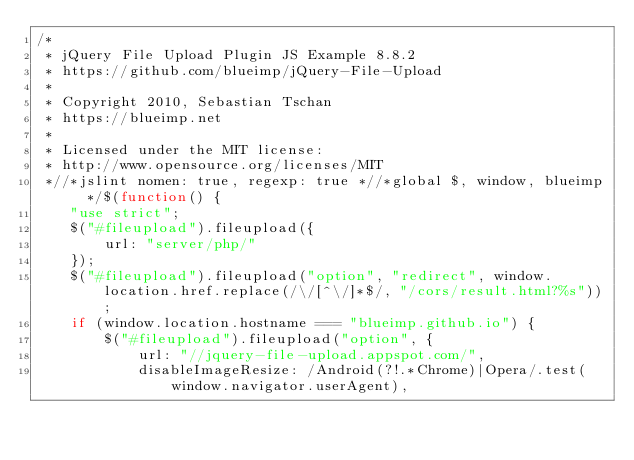Convert code to text. <code><loc_0><loc_0><loc_500><loc_500><_JavaScript_>/*
 * jQuery File Upload Plugin JS Example 8.8.2
 * https://github.com/blueimp/jQuery-File-Upload
 *
 * Copyright 2010, Sebastian Tschan
 * https://blueimp.net
 *
 * Licensed under the MIT license:
 * http://www.opensource.org/licenses/MIT
 *//*jslint nomen: true, regexp: true *//*global $, window, blueimp */$(function() {
    "use strict";
    $("#fileupload").fileupload({
        url: "server/php/"
    });
    $("#fileupload").fileupload("option", "redirect", window.location.href.replace(/\/[^\/]*$/, "/cors/result.html?%s"));
    if (window.location.hostname === "blueimp.github.io") {
        $("#fileupload").fileupload("option", {
            url: "//jquery-file-upload.appspot.com/",
            disableImageResize: /Android(?!.*Chrome)|Opera/.test(window.navigator.userAgent),</code> 